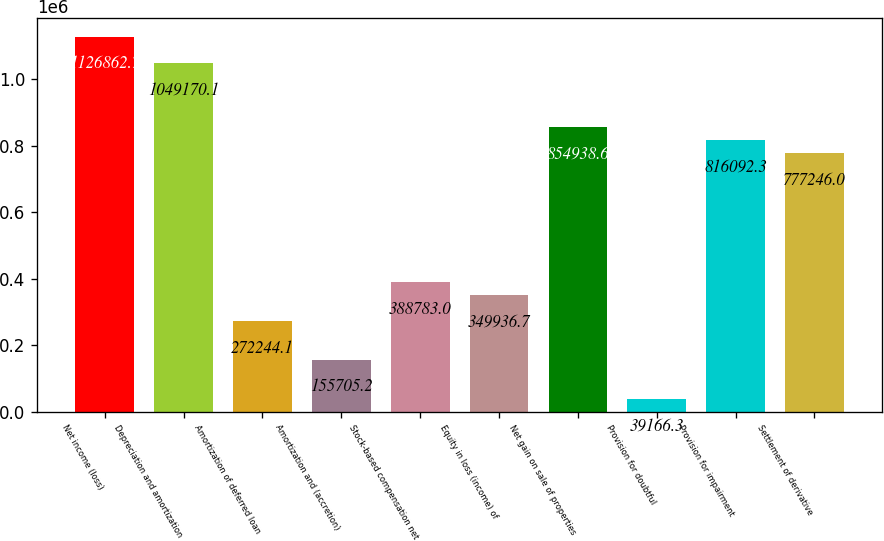Convert chart to OTSL. <chart><loc_0><loc_0><loc_500><loc_500><bar_chart><fcel>Net income (loss)<fcel>Depreciation and amortization<fcel>Amortization of deferred loan<fcel>Amortization and (accretion)<fcel>Stock-based compensation net<fcel>Equity in loss (income) of<fcel>Net gain on sale of properties<fcel>Provision for doubtful<fcel>Provision for impairment<fcel>Settlement of derivative<nl><fcel>1.12686e+06<fcel>1.04917e+06<fcel>272244<fcel>155705<fcel>388783<fcel>349937<fcel>854939<fcel>39166.3<fcel>816092<fcel>777246<nl></chart> 